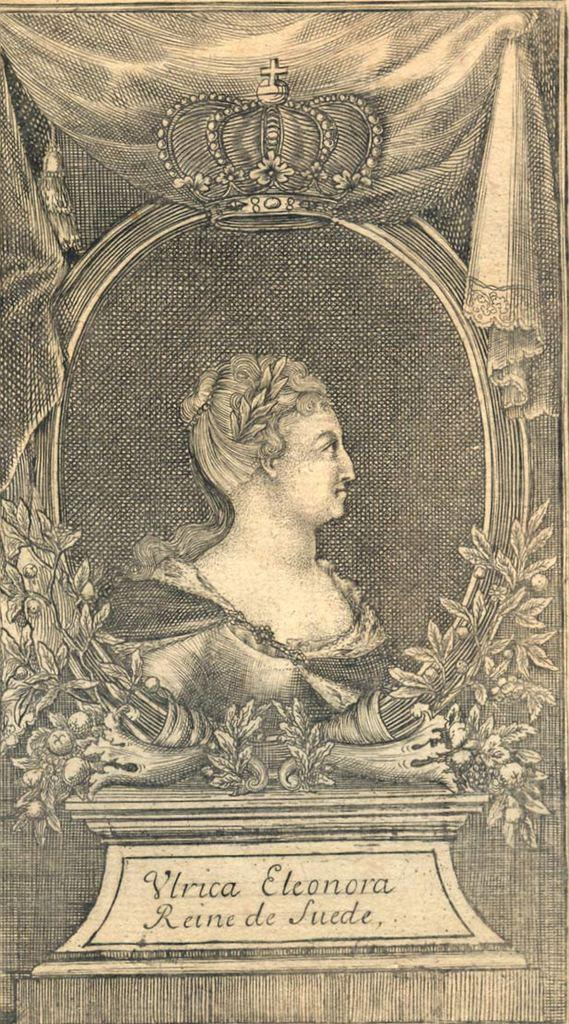What is the main subject of the image? There is a memorial in the image. What type of flesh can be seen on the memorial in the image? There is no flesh present on the memorial in the image. How many fans are visible near the memorial in the image? There are no fans visible in the image. 